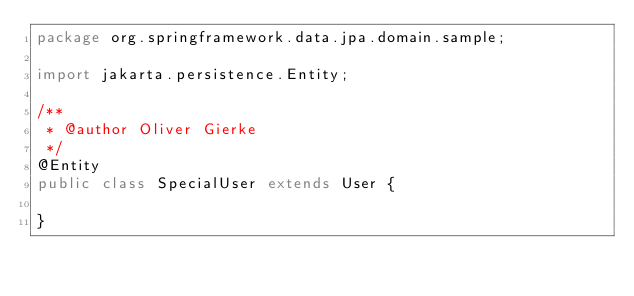Convert code to text. <code><loc_0><loc_0><loc_500><loc_500><_Java_>package org.springframework.data.jpa.domain.sample;

import jakarta.persistence.Entity;

/**
 * @author Oliver Gierke
 */
@Entity
public class SpecialUser extends User {

}
</code> 